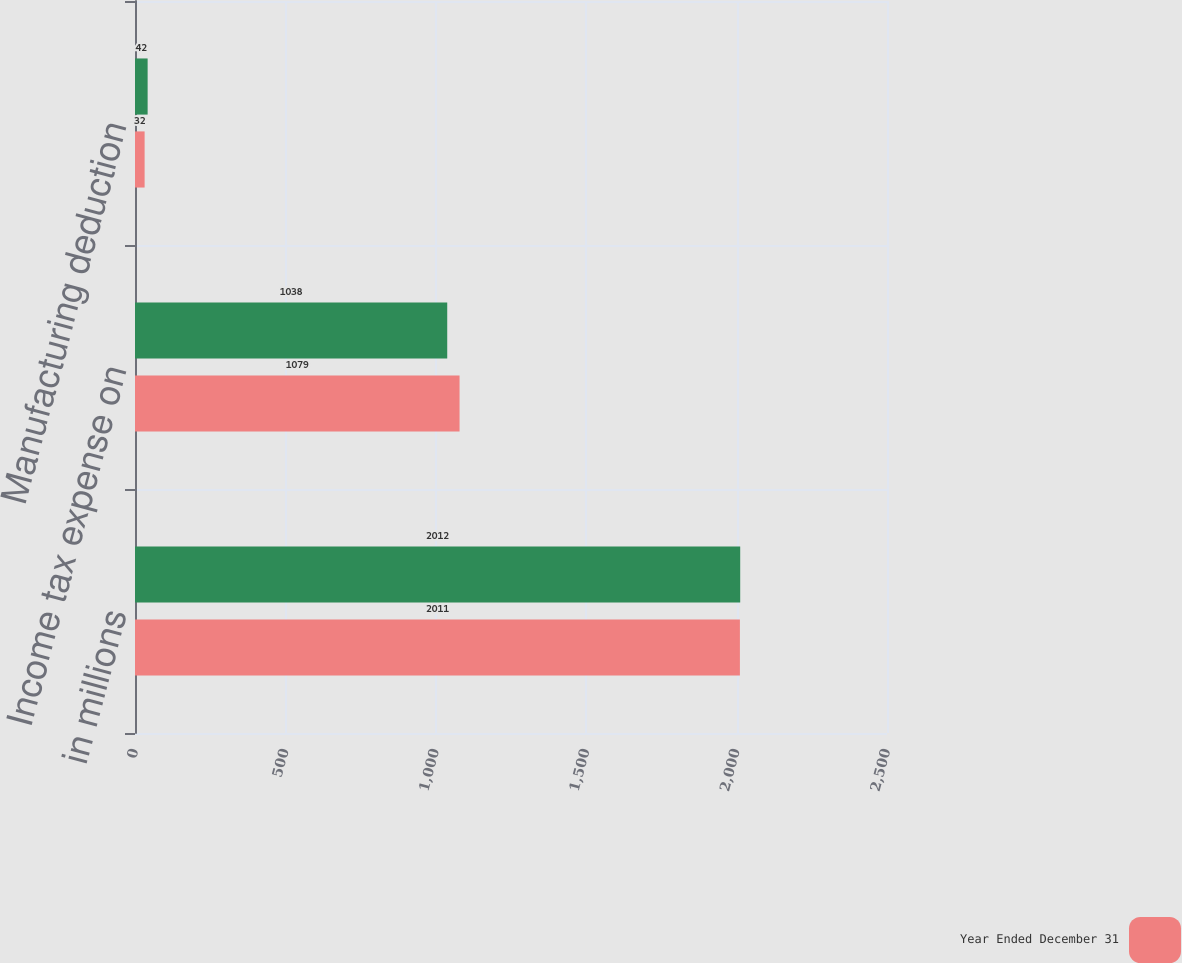Convert chart. <chart><loc_0><loc_0><loc_500><loc_500><stacked_bar_chart><ecel><fcel>in millions<fcel>Income tax expense on<fcel>Manufacturing deduction<nl><fcel>nan<fcel>2012<fcel>1038<fcel>42<nl><fcel>Year Ended December 31<fcel>2011<fcel>1079<fcel>32<nl></chart> 